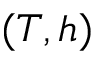<formula> <loc_0><loc_0><loc_500><loc_500>( T , h )</formula> 